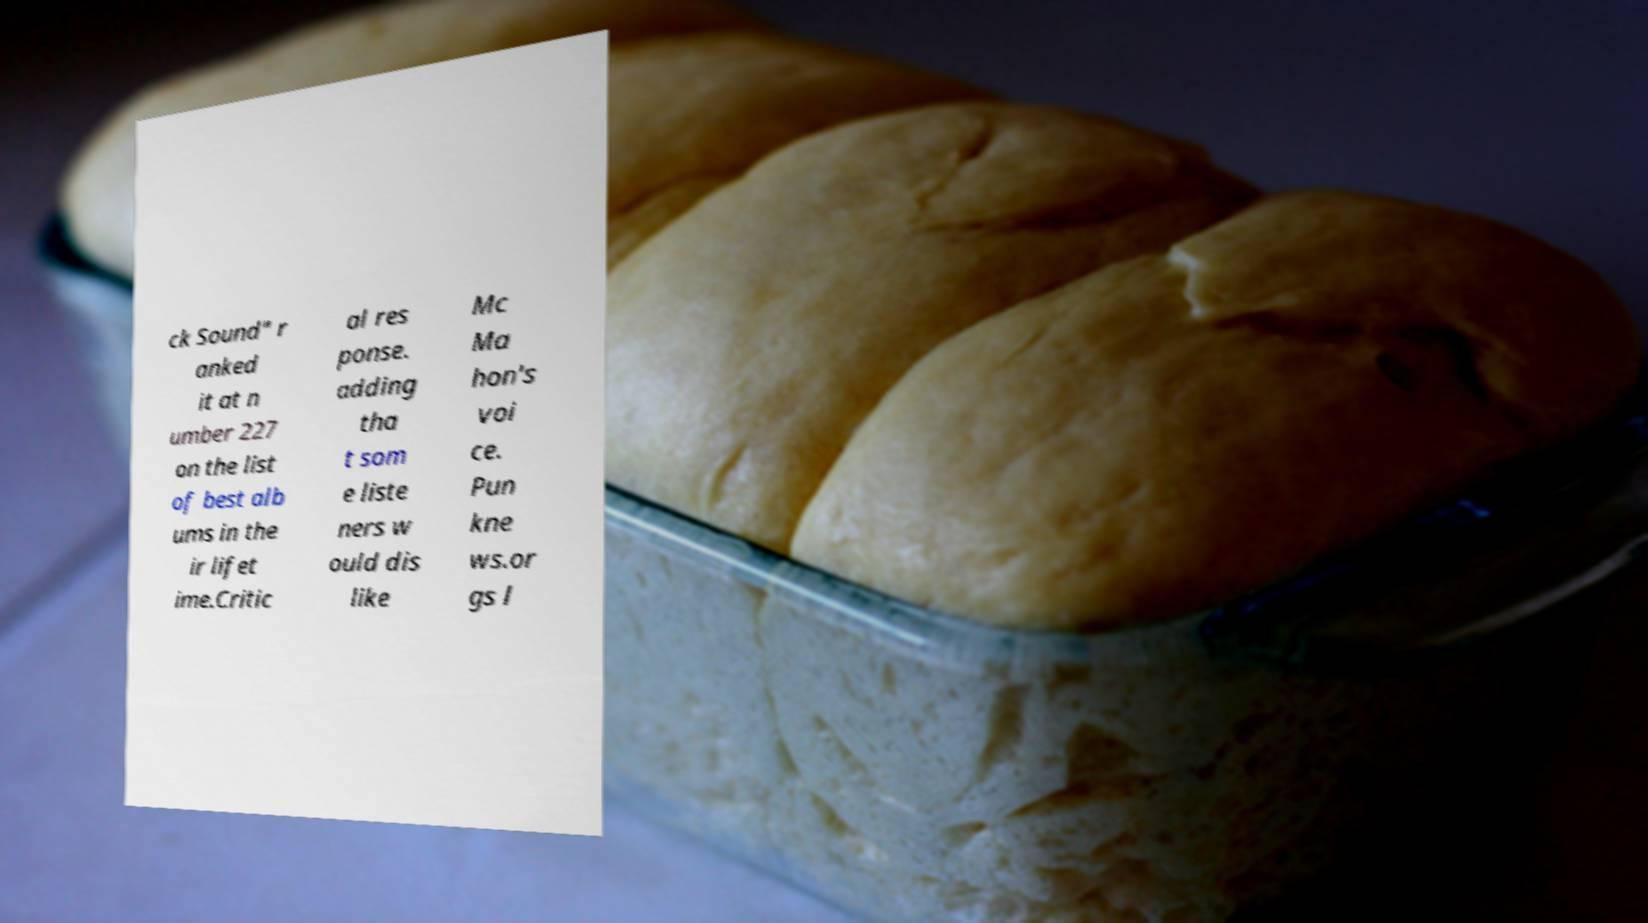There's text embedded in this image that I need extracted. Can you transcribe it verbatim? ck Sound" r anked it at n umber 227 on the list of best alb ums in the ir lifet ime.Critic al res ponse. adding tha t som e liste ners w ould dis like Mc Ma hon's voi ce. Pun kne ws.or gs l 